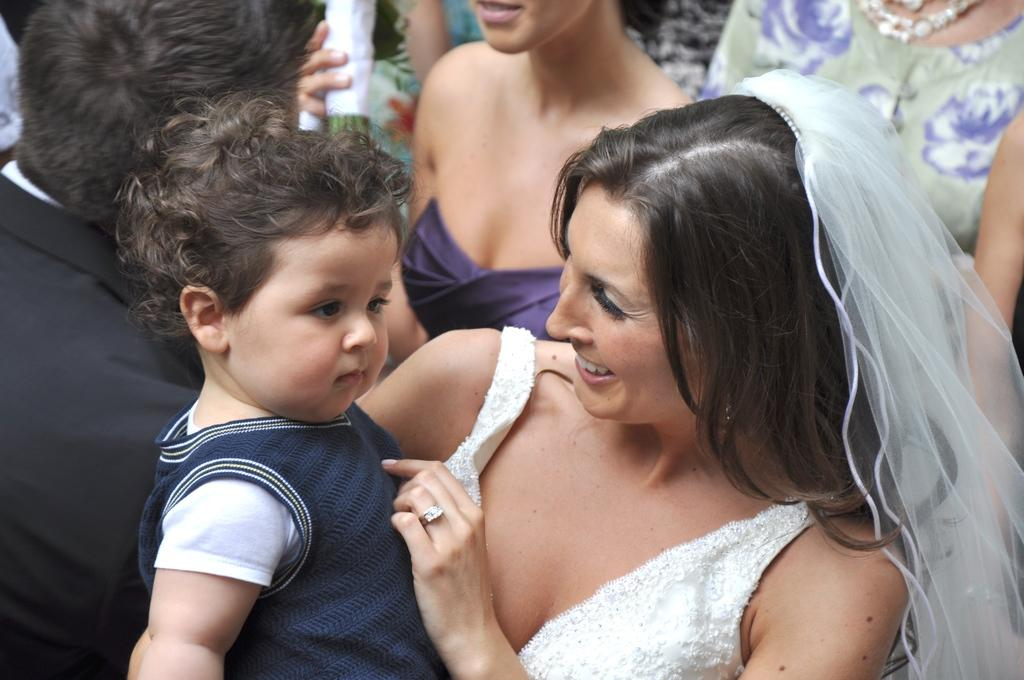How many people are in the image? There is a group of people in the image. Can you describe the clothing of one of the people? One person is wearing a white dress. What is the person in the white dress doing? The person in the white dress is holding a baby. How is the baby dressed? The baby is wearing a white and blue dress. How many patches can be seen on the baby's dress in the image? There are no patches visible on the baby's dress in the image; it is described as a white and blue dress. 